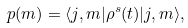Convert formula to latex. <formula><loc_0><loc_0><loc_500><loc_500>p ( m ) = \langle j , m | \rho ^ { s } ( t ) | j , m \rangle ,</formula> 